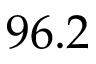Convert formula to latex. <formula><loc_0><loc_0><loc_500><loc_500>9 6 . 2</formula> 